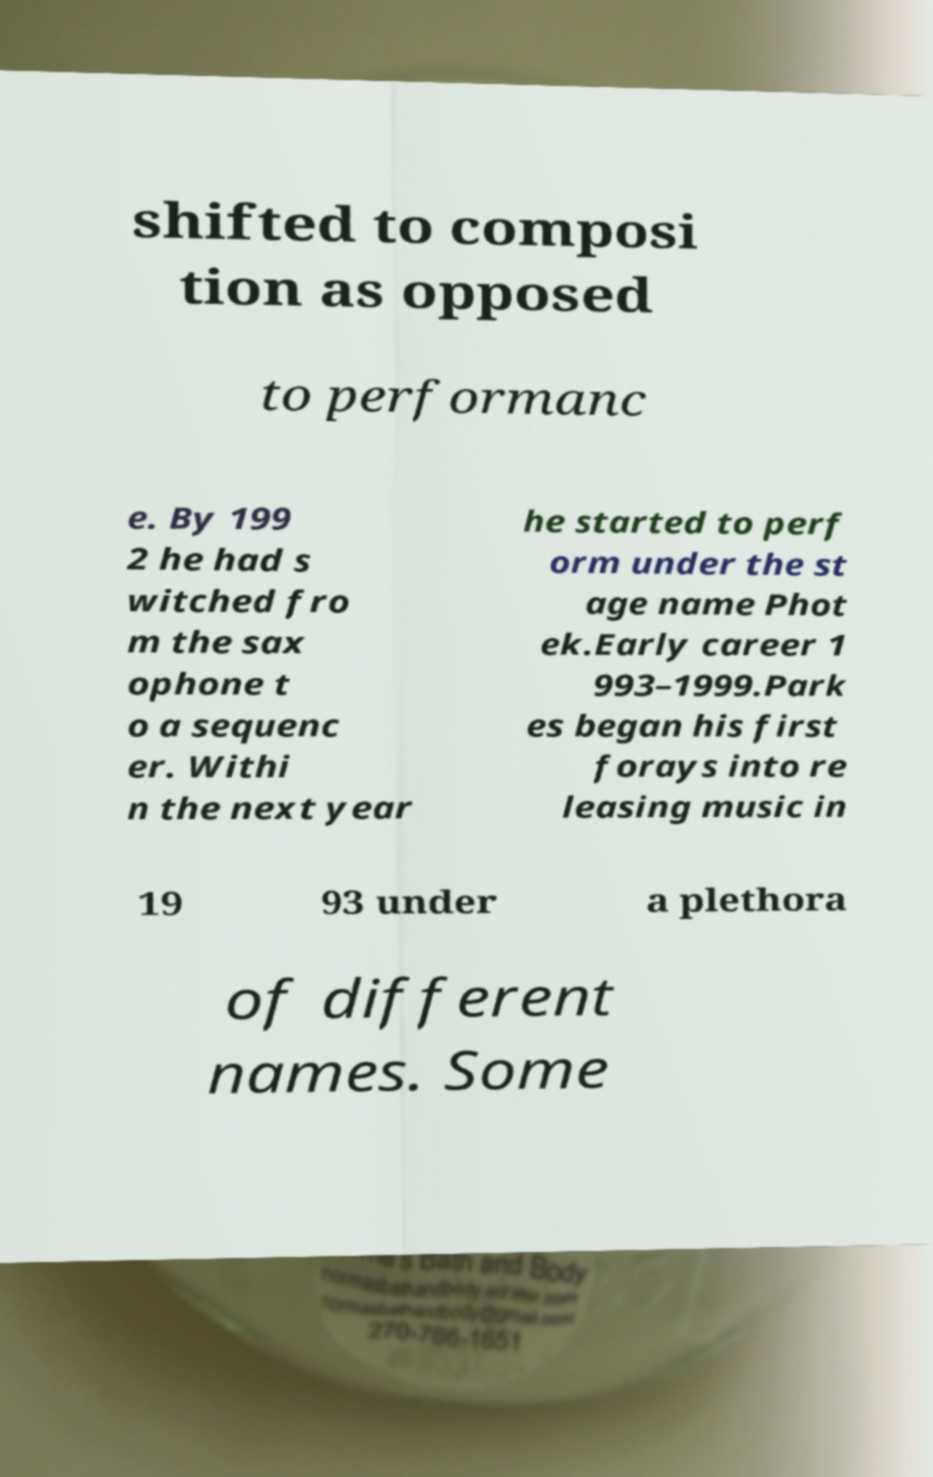Please identify and transcribe the text found in this image. shifted to composi tion as opposed to performanc e. By 199 2 he had s witched fro m the sax ophone t o a sequenc er. Withi n the next year he started to perf orm under the st age name Phot ek.Early career 1 993–1999.Park es began his first forays into re leasing music in 19 93 under a plethora of different names. Some 